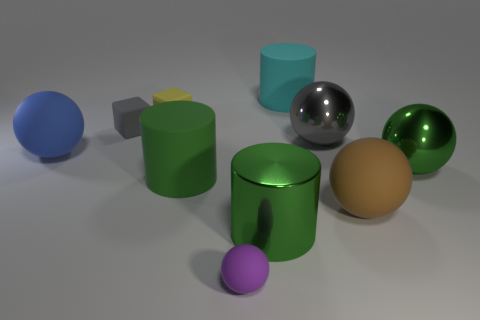Subtract all blue spheres. Subtract all blue blocks. How many spheres are left? 4 Subtract all cylinders. How many objects are left? 7 Subtract 1 yellow cubes. How many objects are left? 9 Subtract all tiny brown shiny blocks. Subtract all big green rubber cylinders. How many objects are left? 9 Add 8 large green shiny cylinders. How many large green shiny cylinders are left? 9 Add 1 metallic spheres. How many metallic spheres exist? 3 